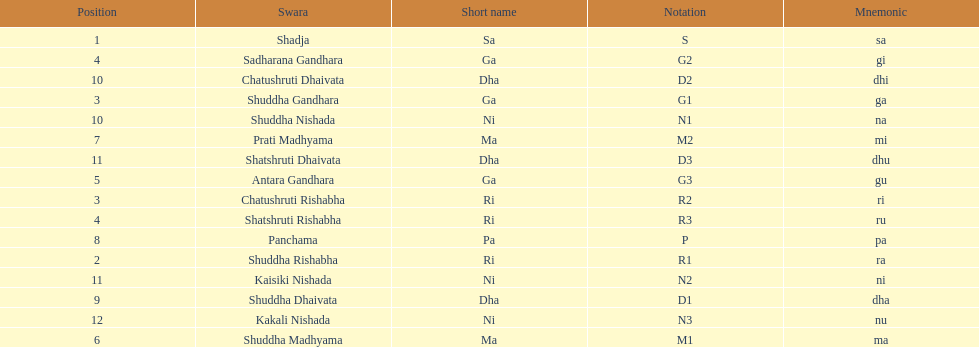How many swaras do not have dhaivata in their name? 13. 